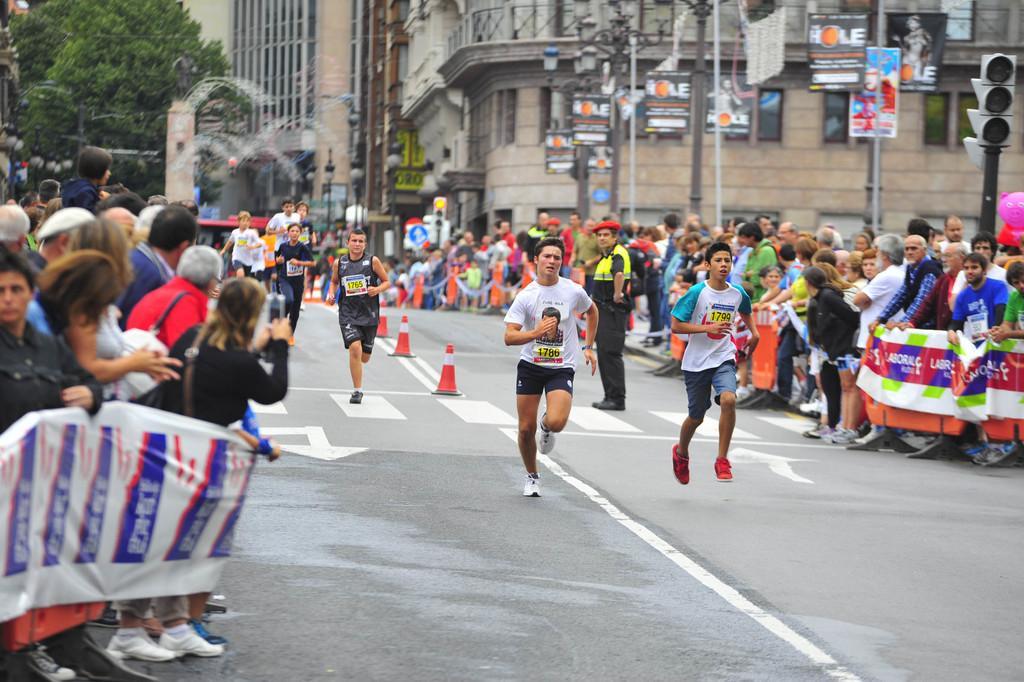Please provide a concise description of this image. At the bottom of the image there is a road. On the road there are few people running. And also there are many people standing and holding posters. In the background there are buildings with walls, pillars, posts and railings. Also there are trees, poles with sign boards, traffic signals and lights. 